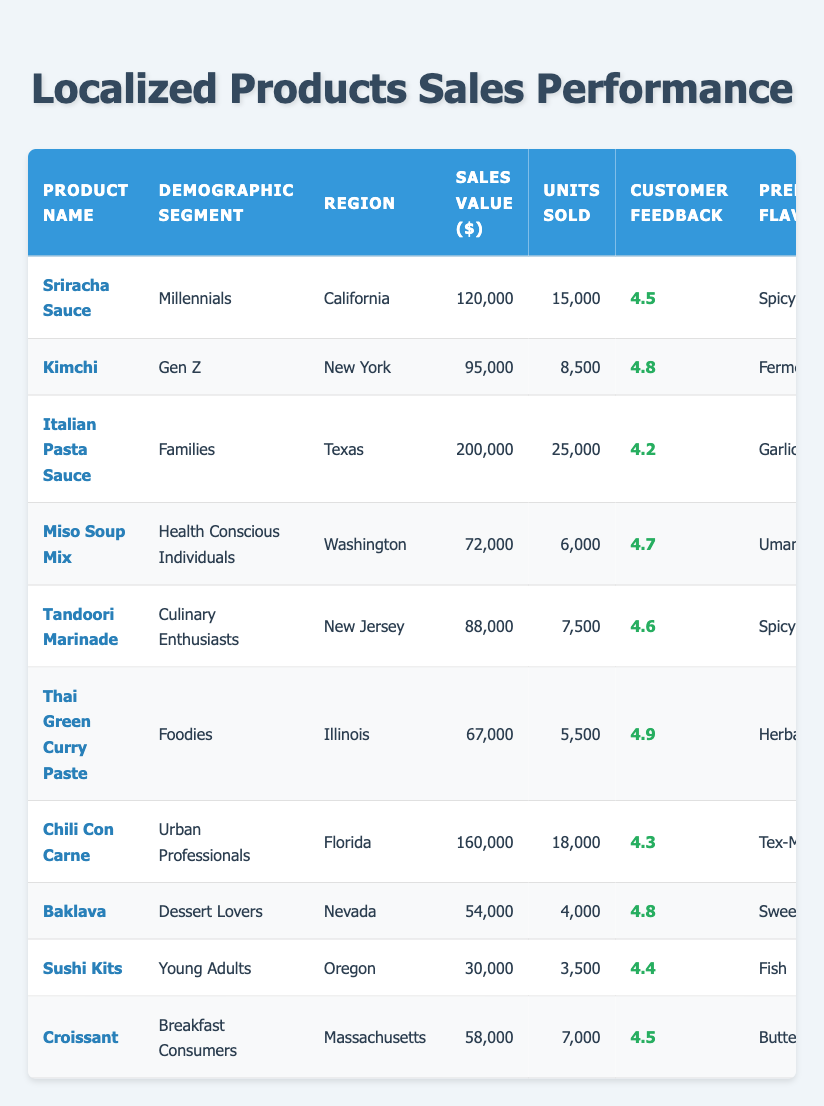What is the sales value of Italian Pasta Sauce? In the table, I can find the value under the "Sales Value ($)" column for the product "Italian Pasta Sauce". It is listed as 200,000.
Answer: 200,000 Which demographic segment had the highest customer feedback score? By comparing all the customer feedback scores listed in the "Customer Feedback" column, "Kimchi" has the highest score of 4.8.
Answer: Kimchi What is the average purchase frequency for products sold in New York? Looking at the products in New York, there are two items: "Kimchi" with an average purchase frequency of 3.0 and "Tandoori Marinade" with 1.9. The average frequency is (3.0 + 1.9) / 2 = 2.45.
Answer: 2.45 Did any product have a sales value of less than 70,000? Reviewing the table, "Miso Soup Mix" has a sales value of 72,000, "Baklava" has 54,000, and "Sushi Kits" has 30,000. Therefore, yes, there are products with a sales value of less than 70,000.
Answer: Yes How many total units were sold across all products? To find the total units sold, I sum the units sold for each product: 15,000 + 8,500 + 25,000 + 6,000 + 7,500 + 5,500 + 18,000 + 4,000 + 3,500 + 7,000 = 100,000.
Answer: 100,000 Which product sold the most units? In the table, by looking at the "Units Sold" column, "Italian Pasta Sauce" has the highest units sold of 25,000.
Answer: Italian Pasta Sauce What demographic segment has the preferred flavor of "Spicy"? The table indicates that both "Sriracha Sauce" and "Tandoori Marinade" have "Spicy" as their preferred flavor, served to Millennials and Culinary Enthusiasts, respectively.
Answer: Millennials and Culinary Enthusiasts Is the average customer feedback score of "Dessert Lovers" greater than 4.5? The "Baklava" is the product for "Dessert Lovers" with a customer feedback score of 4.8, which is indeed greater than 4.5.
Answer: Yes 